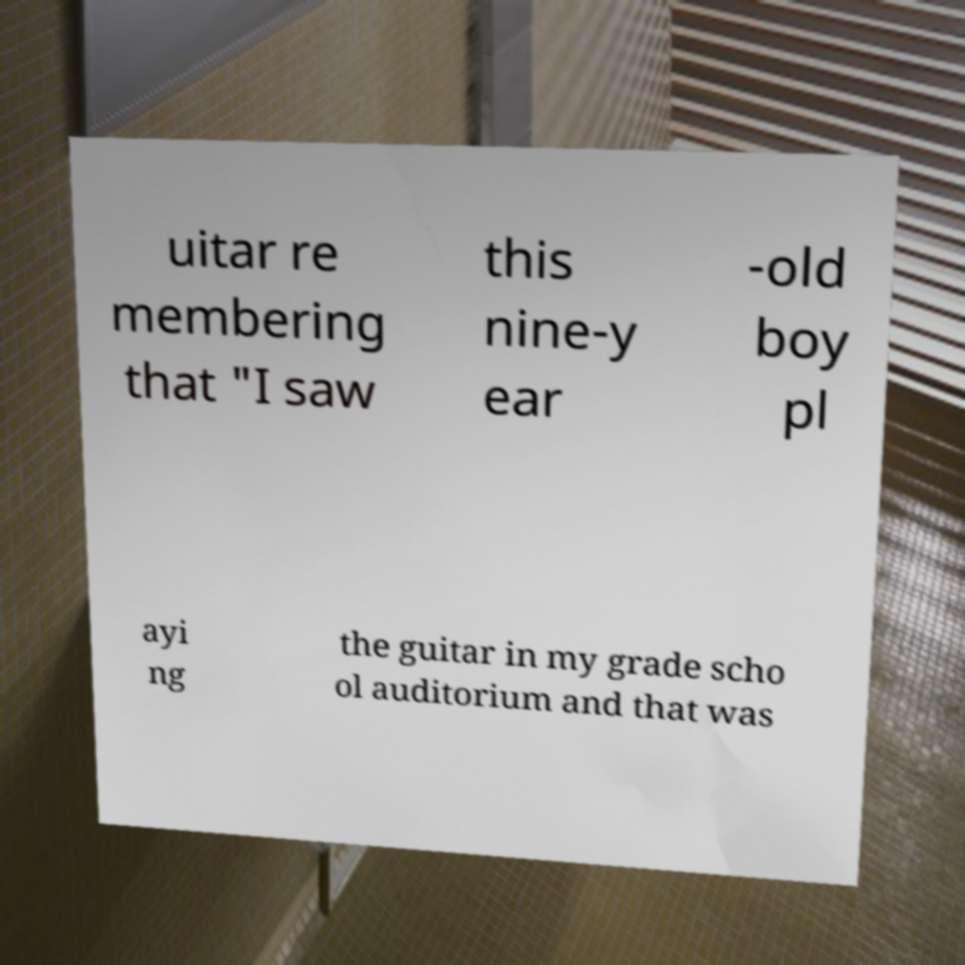I need the written content from this picture converted into text. Can you do that? uitar re membering that "I saw this nine-y ear -old boy pl ayi ng the guitar in my grade scho ol auditorium and that was 